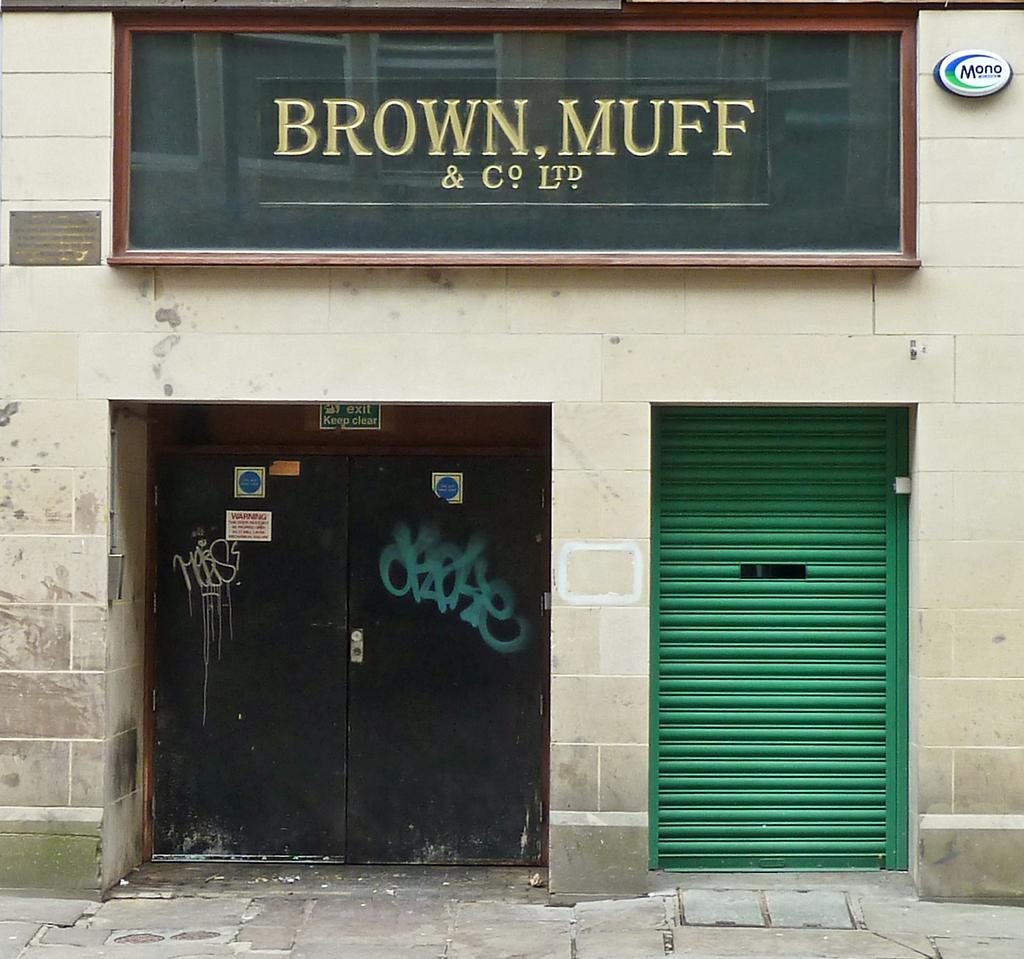What type of openings can be seen in the image? There are doors in the image. What can be used to control light or air in the image? There is a shutter in the image. What is located at the top of the image? There is a hoarding at the top of the image. What is written or displayed on the hoarding? There is text on the hoarding. Can you see any crows perched on the wire in the image? There is no wire or crow present in the image. Is there any water visible in the image? There is no water present in the image. 